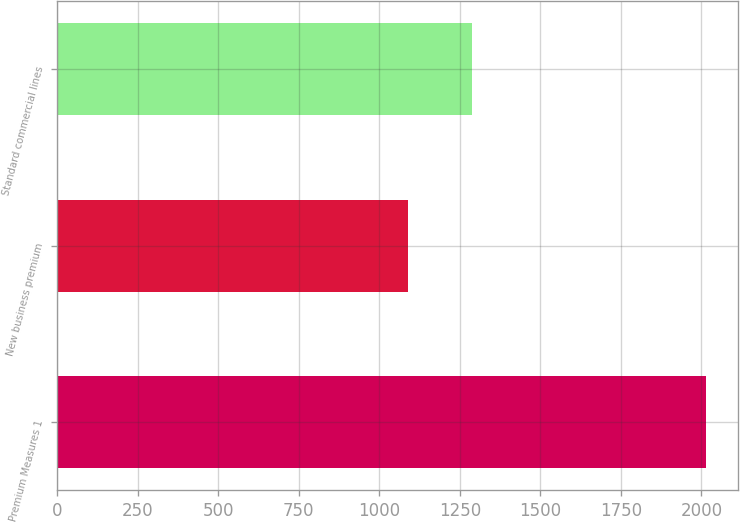Convert chart to OTSL. <chart><loc_0><loc_0><loc_500><loc_500><bar_chart><fcel>Premium Measures 1<fcel>New business premium<fcel>Standard commercial lines<nl><fcel>2014<fcel>1088<fcel>1288.9<nl></chart> 